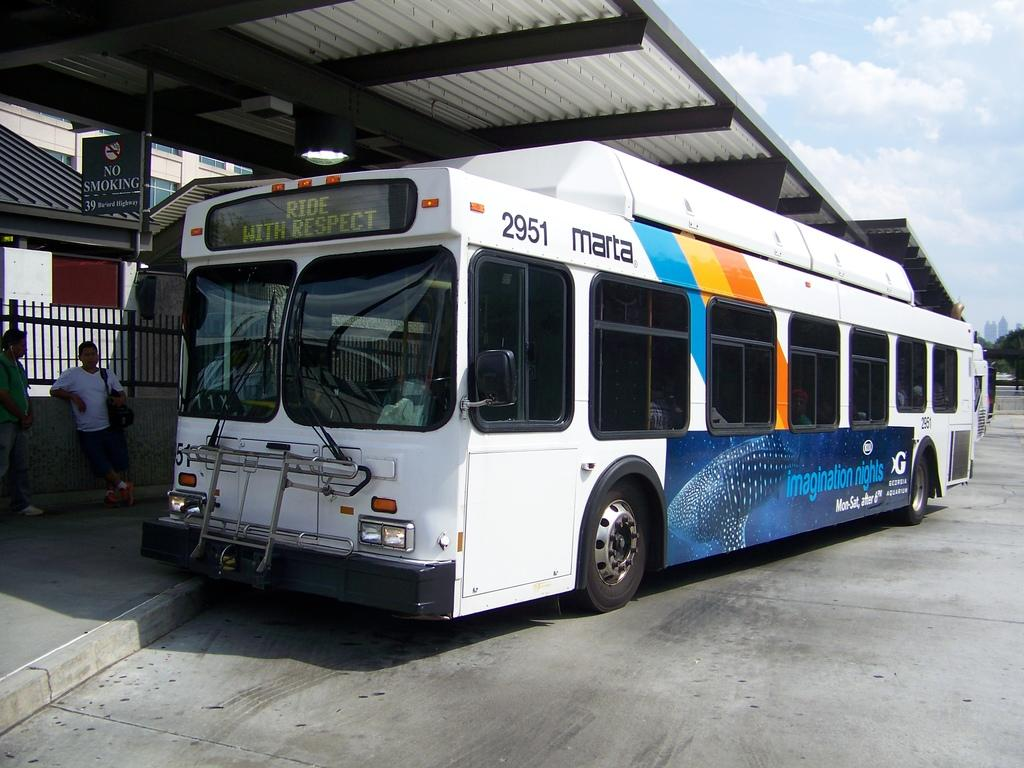Who or what can be seen in the image? There are people in the image. What mode of transportation is present in the image? There is a bus in the image. Where is the bus located? The bus is in a shelter. What can be seen in the background of the image? There is a building, a board, trees, and the sky visible in the background of the image. How does the limit affect the people in the image? There is no mention of a limit in the image, so it cannot be determined how it affects the people. 